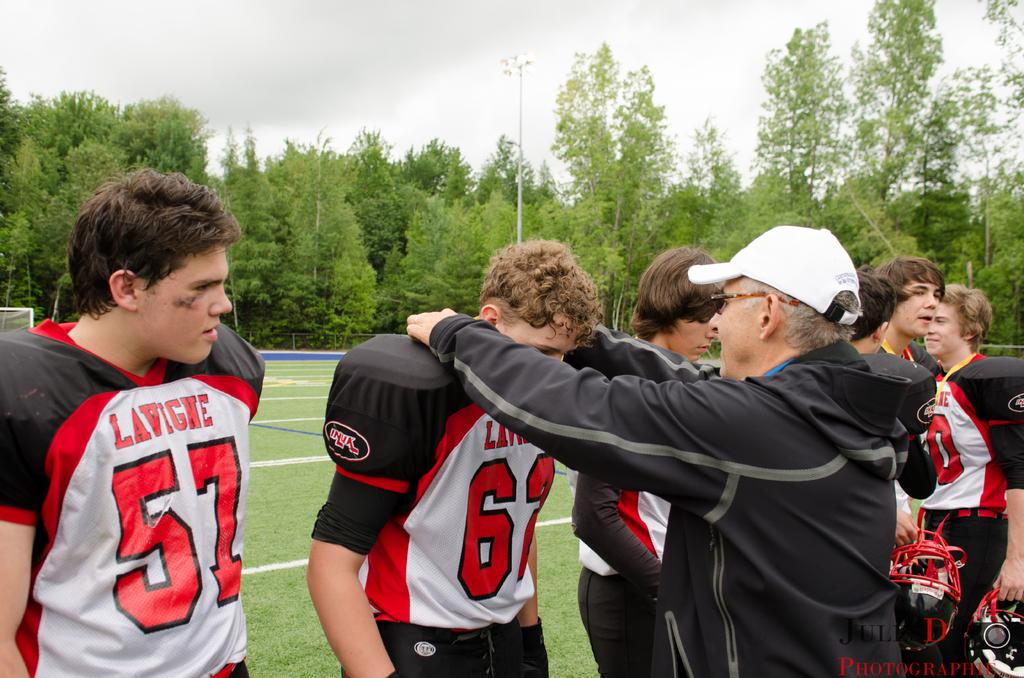What are the people in the image doing? The persons standing on the ground in the image are likely standing or interacting with each other. What can be seen at the bottom of the image? The ground is visible at the bottom of the image. What type of vegetation is in the background of the image? There are trees in the background of the image. What is visible at the top of the image? The sky is visible at the top of the image. How many geese are flying in the winter sky in the image? There are no geese or indication of winter in the image; it features persons standing on the ground with trees in the background and the sky visible at the top. 